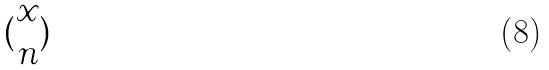<formula> <loc_0><loc_0><loc_500><loc_500>( \begin{matrix} x \\ n \end{matrix} )</formula> 